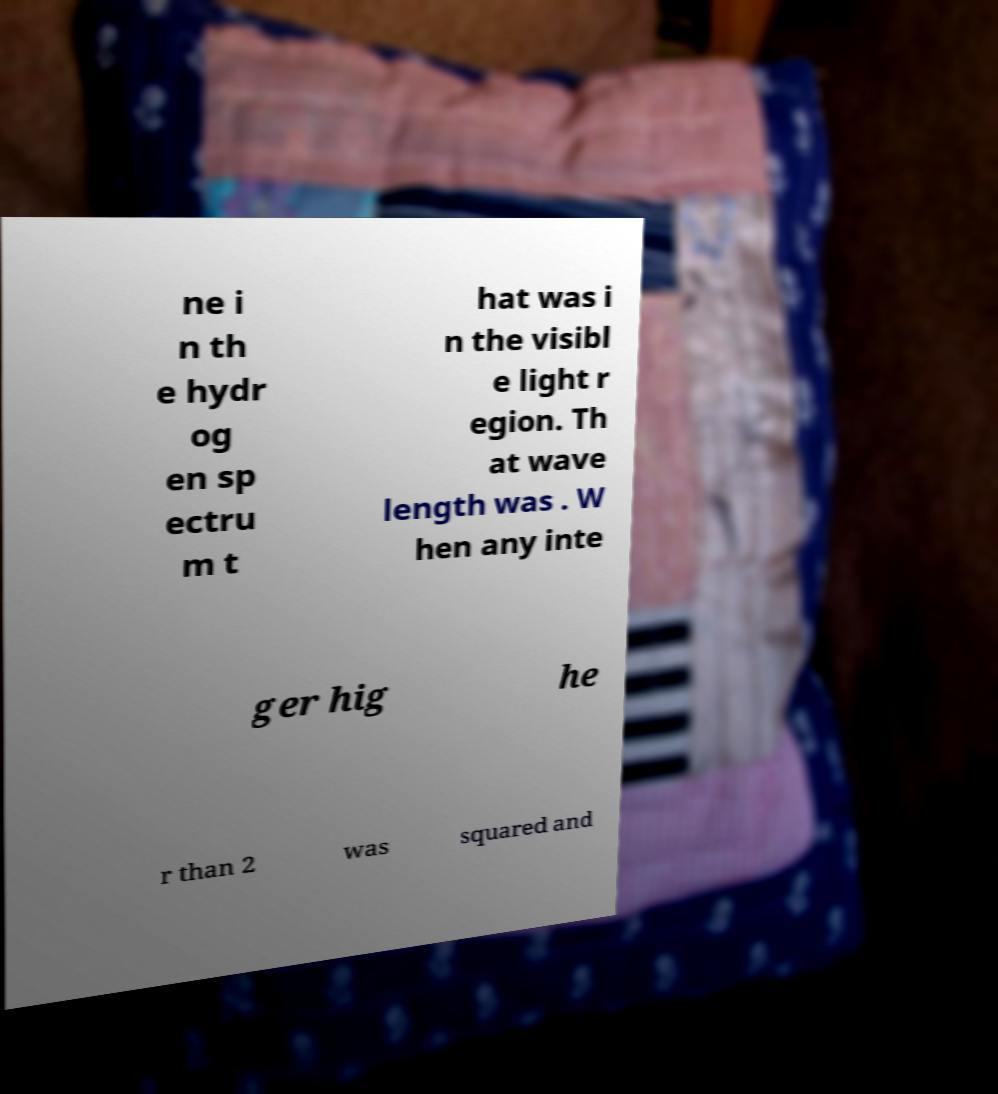I need the written content from this picture converted into text. Can you do that? ne i n th e hydr og en sp ectru m t hat was i n the visibl e light r egion. Th at wave length was . W hen any inte ger hig he r than 2 was squared and 